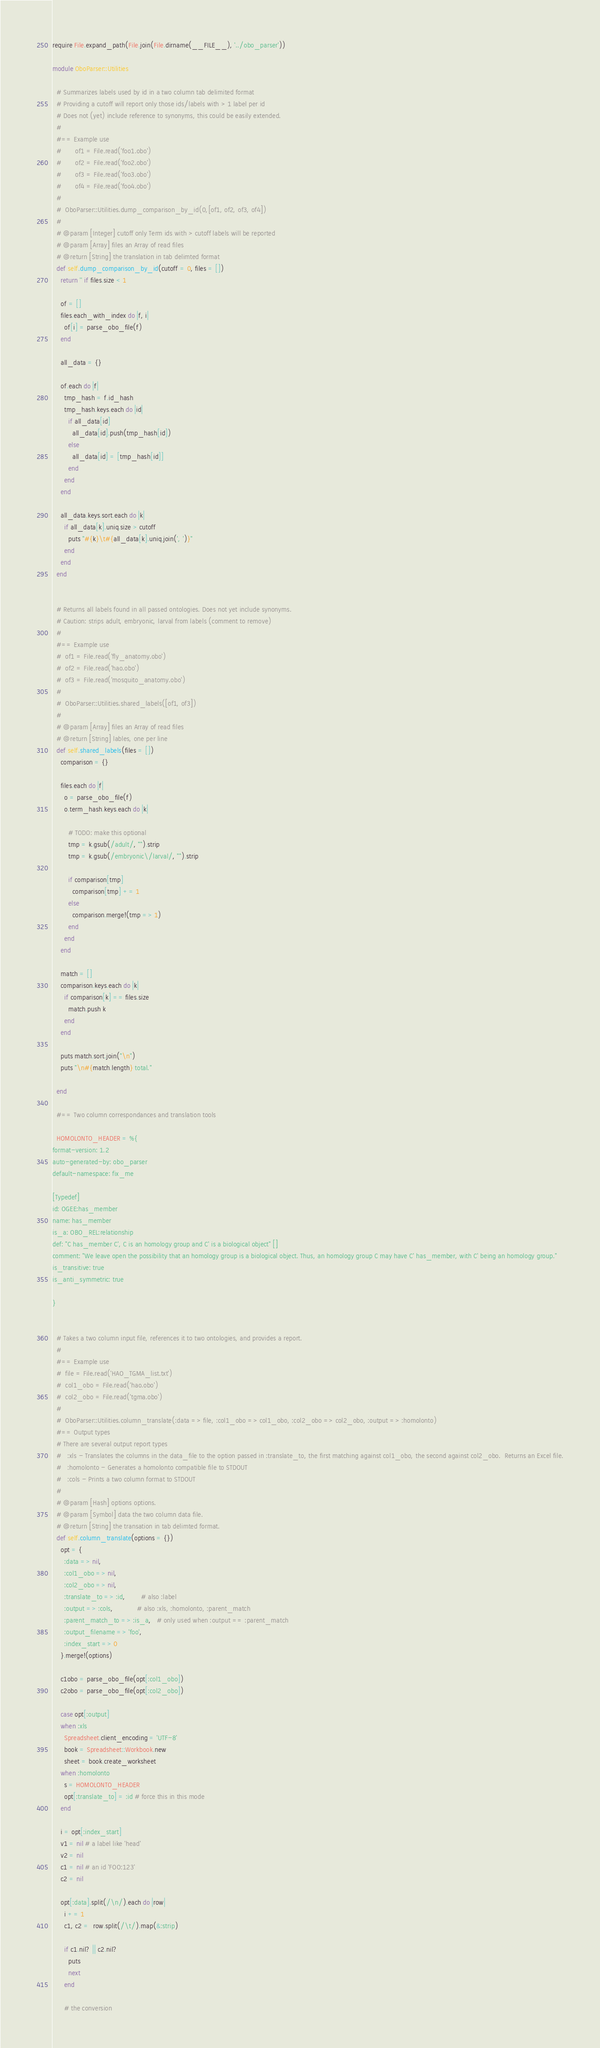Convert code to text. <code><loc_0><loc_0><loc_500><loc_500><_Ruby_>require File.expand_path(File.join(File.dirname(__FILE__), '../obo_parser')) 

module OboParser::Utilities

  # Summarizes labels used by id in a two column tab delimited format 
  # Providing a cutoff will report only those ids/labels with > 1 label per id
  # Does not (yet) include reference to synonyms, this could be easily extended.
  #
  #== Example use
  #		of1 = File.read('foo1.obo')	
  #		of2 = File.read('foo2.obo')	
  #		of3 = File.read('foo3.obo')	
  #		of4 = File.read('foo4.obo')	
  # 
  #  OboParser::Utilities.dump_comparison_by_id(0,[of1, of2, of3, of4])
  #
  # @param [Integer] cutoff only Term ids with > cutoff labels will be reported 
  # @param [Array] files an Array of read files 
  # @return [String] the translation in tab delimted format
  def self.dump_comparison_by_id(cutoff = 0, files = [])
    return '' if files.size < 1

    of = [] 
    files.each_with_index do |f, i|
      of[i] = parse_obo_file(f)	
    end

    all_data = {}

    of.each do |f|
      tmp_hash = f.id_hash
      tmp_hash.keys.each do |id|
        if all_data[id]
          all_data[id].push(tmp_hash[id])
        else
          all_data[id] = [tmp_hash[id]]
        end
      end
    end

    all_data.keys.sort.each do |k|
      if all_data[k].uniq.size > cutoff 
        puts "#{k}\t#{all_data[k].uniq.join(', ')}"
      end
    end
  end


  # Returns all labels found in all passed ontologies. Does not yet include synonyms.
  # Caution: strips adult, embryonic, larval from labels (comment to remove)
  #
  #== Example use
  #  of1 = File.read('fly_anatomy.obo')	
  #  of2 = File.read('hao.obo')	
  #  of3 = File.read('mosquito_anatomy.obo')	
  # 
  #  OboParser::Utilities.shared_labels([of1, of3])
  #
  # @param [Array] files an Array of read files 
  # @return [String] lables, one per line
  def self.shared_labels(files = []) 
    comparison = {}

    files.each do |f|
      o = parse_obo_file(f)
      o.term_hash.keys.each do |k|

        # TODO: make this optional 
        tmp = k.gsub(/adult/, "").strip
        tmp = k.gsub(/embryonic\/larval/, "").strip

        if comparison[tmp]
          comparison[tmp] += 1
        else
          comparison.merge!(tmp => 1)
        end
      end
    end

    match = [] 
    comparison.keys.each do |k|
      if comparison[k] == files.size 
        match.push k
      end
    end

    puts match.sort.join("\n")
    puts "\n#{match.length} total."

  end 

  #== Two column correspondances and translation tools

  HOMOLONTO_HEADER = %{
format-version: 1.2
auto-generated-by: obo_parser
default-namespace: fix_me

[Typedef]
id: OGEE:has_member
name: has_member
is_a: OBO_REL:relationship
def: "C has_member C', C is an homology group and C' is a biological object" []
comment: "We leave open the possibility that an homology group is a biological object. Thus, an homology group C may have C' has_member, with C' being an homology group."
is_transitive: true
is_anti_symmetric: true

}


  # Takes a two column input file, references it to two ontologies, and provides a report.
  #  
  #== Example use
  #  file = File.read('HAO_TGMA_list.txt')
  #  col1_obo = File.read('hao.obo')
  #  col2_obo = File.read('tgma.obo')
  #  
  #  OboParser::Utilities.column_translate(:data => file, :col1_obo => col1_obo, :col2_obo => col2_obo, :output => :homolonto)
  #== Output types
  # There are several output report types
  #   :xls - Translates the columns in the data_file to the option passed in :translate_to, the first matching against col1_obo, the second against col2_obo.  Returns an Excel file.
  #   :homolonto - Generates a homolonto compatible file to STDOUT
  #   :cols - Prints a two column format to STDOUT
  #
  # @param [Hash] options options.
  # @param [Symbol] data the two column data file.
  # @return [String] the transation in tab delimted format.
  def self.column_translate(options = {})
    opt = {
      :data => nil,
      :col1_obo => nil,
      :col2_obo => nil,
      :translate_to => :id,        # also :label
      :output => :cols,            # also :xls, :homolonto, :parent_match
      :parent_match_to => :is_a,   # only used when :output == :parent_match
      :output_filename => 'foo',
      :index_start => 0
    }.merge!(options)

    c1obo = parse_obo_file(opt[:col1_obo])
    c2obo = parse_obo_file(opt[:col2_obo])

    case opt[:output]
    when :xls
      Spreadsheet.client_encoding = 'UTF-8'
      book = Spreadsheet::Workbook.new
      sheet = book.create_worksheet
    when :homolonto
      s = HOMOLONTO_HEADER
      opt[:translate_to] = :id # force this in this mode
    end

    i = opt[:index_start]
    v1 = nil # a label like 'head'
    v2 = nil
    c1 = nil # an id 'FOO:123'
    c2 = nil

    opt[:data].split(/\n/).each do |row|
      i += 1
      c1, c2 =  row.split(/\t/).map(&:strip)

      if c1.nil? || c2.nil?
        puts
        next
      end

      # the conversion</code> 